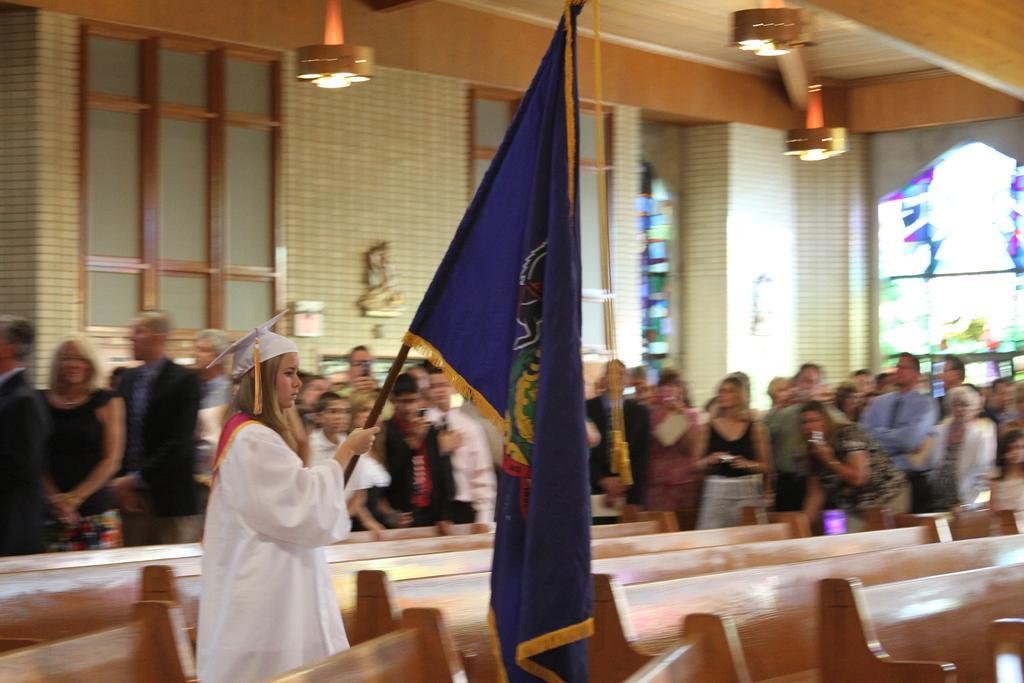Describe this image in one or two sentences. In a hall there a girl,she is holding a flag in her hand and she is wearing a white costume. Behind the girl there are plenty of people standing and watching her,in the background there are plenty of windows and a wall. 